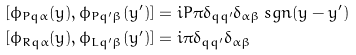<formula> <loc_0><loc_0><loc_500><loc_500>[ \phi _ { P q \alpha } ( y ) , \phi _ { P q ^ { \prime } \beta } ( y ^ { \prime } ) ] & = i P \pi \delta _ { q q ^ { \prime } } \delta _ { \alpha \beta } \, s g n ( y - y ^ { \prime } ) \\ [ \phi _ { R q \alpha } ( y ) , \phi _ { L q ^ { \prime } \beta } ( y ^ { \prime } ) ] & = i \pi \delta _ { q q ^ { \prime } } \delta _ { \alpha \beta }</formula> 